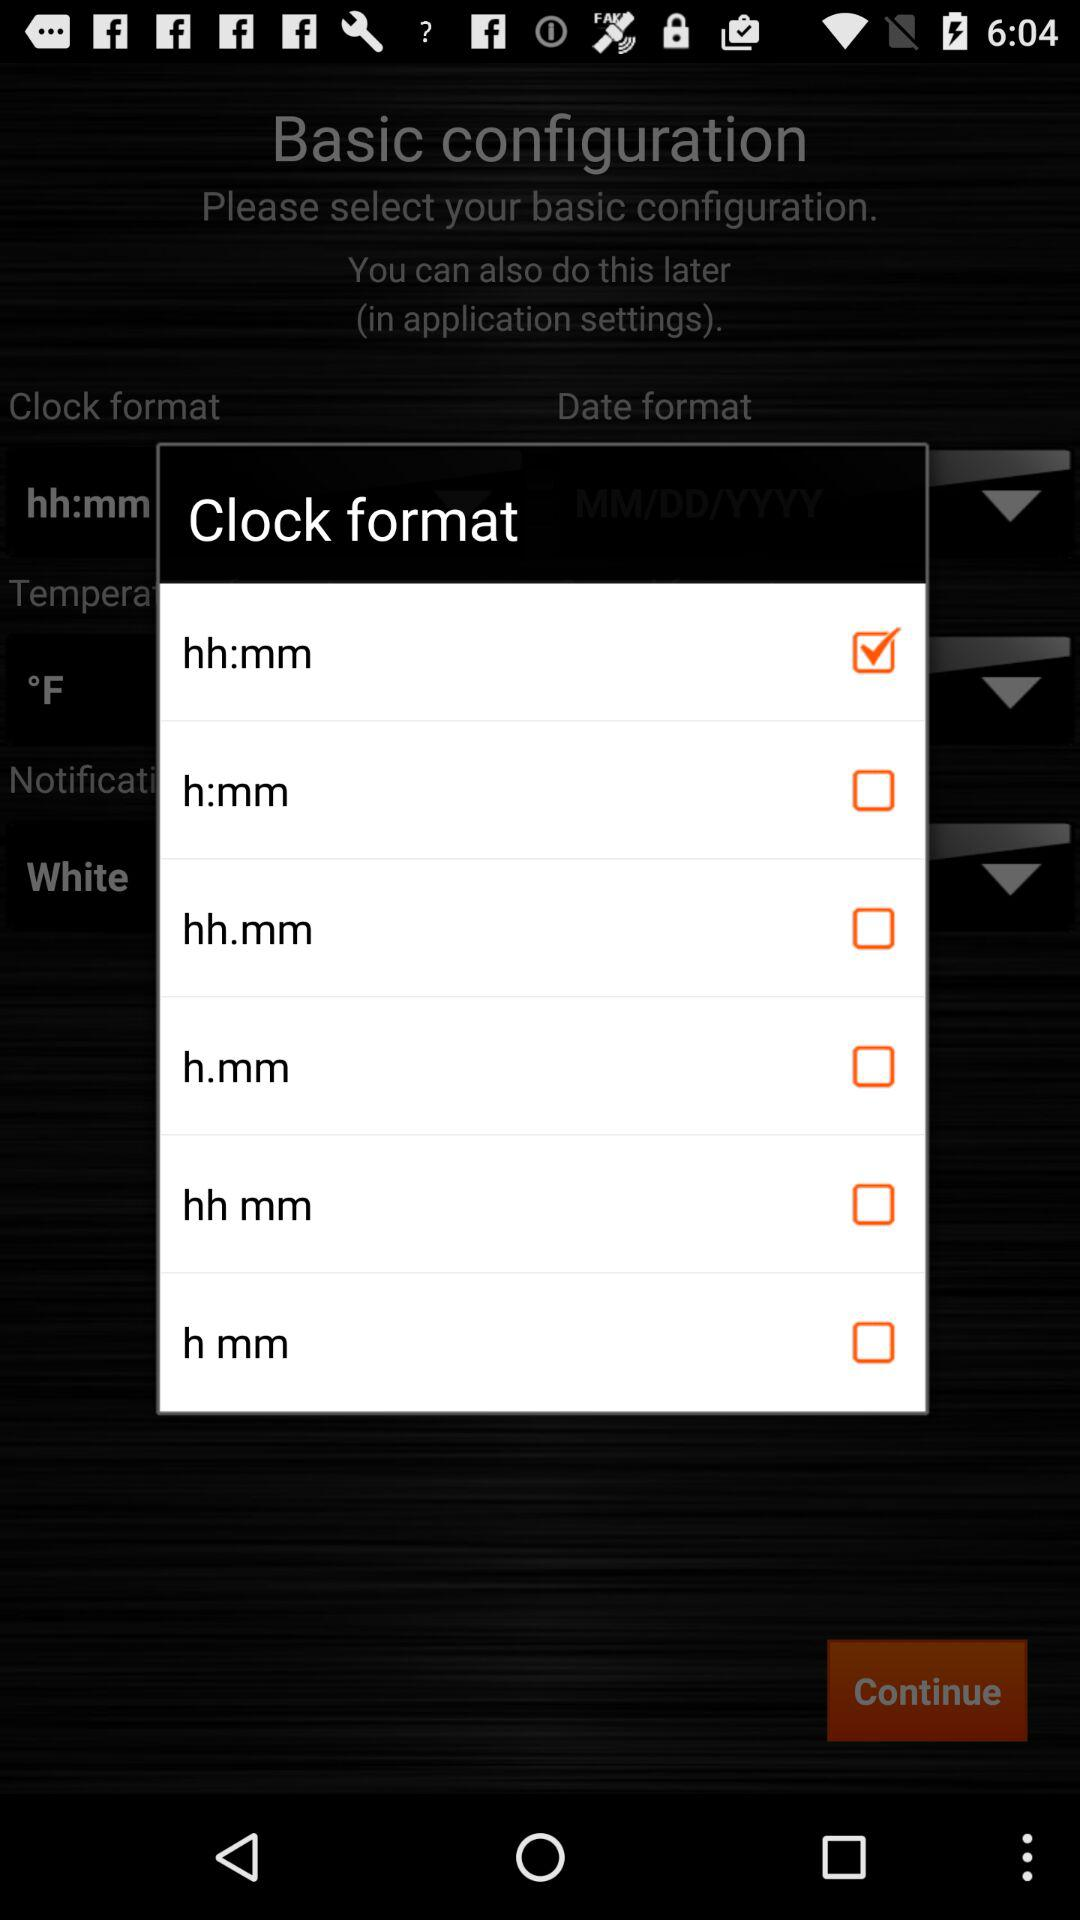How many checkboxes are on the screen?
Answer the question using a single word or phrase. 6 